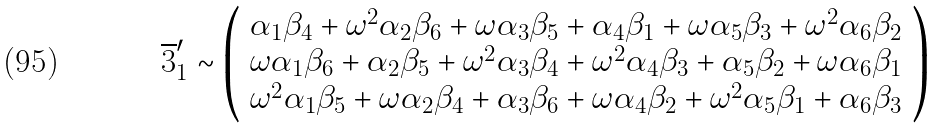<formula> <loc_0><loc_0><loc_500><loc_500>\overline { 3 } ^ { \prime } _ { 1 } \sim \left ( \begin{array} { c } \alpha _ { 1 } \beta _ { 4 } + \omega ^ { 2 } \alpha _ { 2 } \beta _ { 6 } + \omega \alpha _ { 3 } \beta _ { 5 } + \alpha _ { 4 } \beta _ { 1 } + \omega \alpha _ { 5 } \beta _ { 3 } + \omega ^ { 2 } \alpha _ { 6 } \beta _ { 2 } \\ \omega \alpha _ { 1 } \beta _ { 6 } + \alpha _ { 2 } \beta _ { 5 } + \omega ^ { 2 } \alpha _ { 3 } \beta _ { 4 } + \omega ^ { 2 } \alpha _ { 4 } \beta _ { 3 } + \alpha _ { 5 } \beta _ { 2 } + \omega \alpha _ { 6 } \beta _ { 1 } \\ \omega ^ { 2 } \alpha _ { 1 } \beta _ { 5 } + \omega \alpha _ { 2 } \beta _ { 4 } + \alpha _ { 3 } \beta _ { 6 } + \omega \alpha _ { 4 } \beta _ { 2 } + \omega ^ { 2 } \alpha _ { 5 } \beta _ { 1 } + \alpha _ { 6 } \beta _ { 3 } \end{array} \right )</formula> 